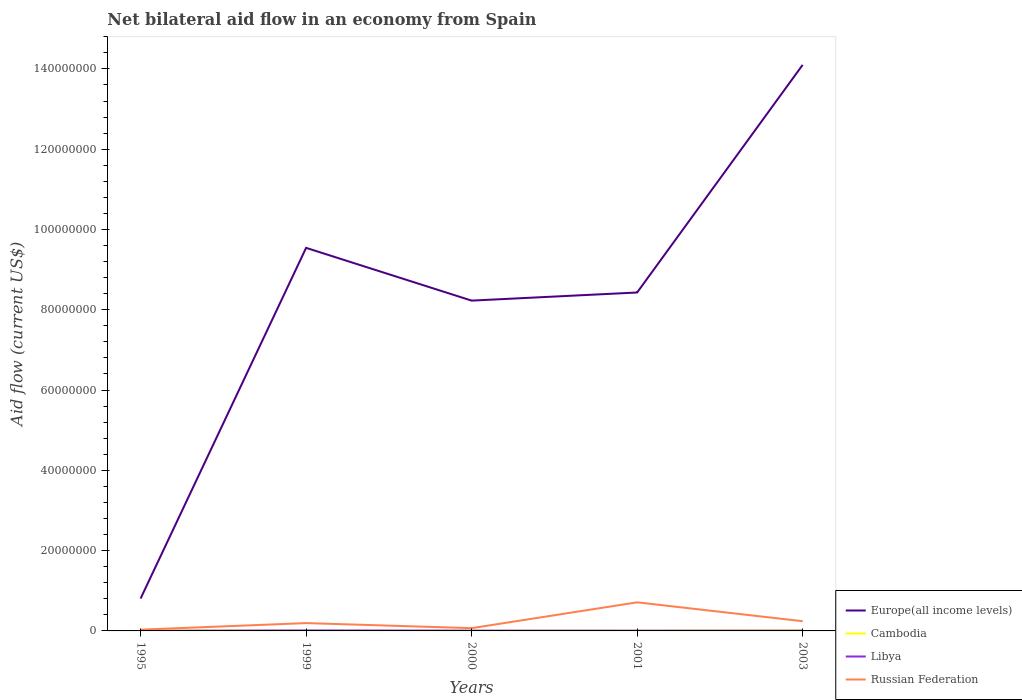How many different coloured lines are there?
Offer a terse response. 4. Is the number of lines equal to the number of legend labels?
Your answer should be very brief. Yes. Across all years, what is the maximum net bilateral aid flow in Europe(all income levels)?
Offer a very short reply. 8.07e+06. What is the total net bilateral aid flow in Europe(all income levels) in the graph?
Offer a very short reply. 1.31e+07. What is the difference between the highest and the second highest net bilateral aid flow in Russian Federation?
Keep it short and to the point. 6.81e+06. What is the difference between the highest and the lowest net bilateral aid flow in Libya?
Offer a terse response. 2. Is the net bilateral aid flow in Europe(all income levels) strictly greater than the net bilateral aid flow in Libya over the years?
Provide a short and direct response. No. How many years are there in the graph?
Your answer should be very brief. 5. What is the title of the graph?
Keep it short and to the point. Net bilateral aid flow in an economy from Spain. What is the Aid flow (current US$) of Europe(all income levels) in 1995?
Give a very brief answer. 8.07e+06. What is the Aid flow (current US$) in Cambodia in 1995?
Offer a terse response. 1.20e+05. What is the Aid flow (current US$) in Libya in 1995?
Provide a succinct answer. 2.00e+04. What is the Aid flow (current US$) in Europe(all income levels) in 1999?
Provide a succinct answer. 9.54e+07. What is the Aid flow (current US$) in Cambodia in 1999?
Ensure brevity in your answer.  2.00e+04. What is the Aid flow (current US$) in Libya in 1999?
Make the answer very short. 1.20e+05. What is the Aid flow (current US$) in Russian Federation in 1999?
Make the answer very short. 1.95e+06. What is the Aid flow (current US$) of Europe(all income levels) in 2000?
Make the answer very short. 8.23e+07. What is the Aid flow (current US$) of Libya in 2000?
Ensure brevity in your answer.  7.00e+04. What is the Aid flow (current US$) in Russian Federation in 2000?
Give a very brief answer. 6.90e+05. What is the Aid flow (current US$) of Europe(all income levels) in 2001?
Ensure brevity in your answer.  8.43e+07. What is the Aid flow (current US$) of Libya in 2001?
Your answer should be very brief. 6.00e+04. What is the Aid flow (current US$) of Russian Federation in 2001?
Your response must be concise. 7.12e+06. What is the Aid flow (current US$) in Europe(all income levels) in 2003?
Your response must be concise. 1.41e+08. What is the Aid flow (current US$) of Cambodia in 2003?
Your answer should be compact. 1.20e+05. What is the Aid flow (current US$) in Libya in 2003?
Offer a very short reply. 6.00e+04. What is the Aid flow (current US$) of Russian Federation in 2003?
Ensure brevity in your answer.  2.42e+06. Across all years, what is the maximum Aid flow (current US$) in Europe(all income levels)?
Provide a short and direct response. 1.41e+08. Across all years, what is the maximum Aid flow (current US$) in Cambodia?
Offer a terse response. 1.20e+05. Across all years, what is the maximum Aid flow (current US$) of Russian Federation?
Give a very brief answer. 7.12e+06. Across all years, what is the minimum Aid flow (current US$) of Europe(all income levels)?
Give a very brief answer. 8.07e+06. Across all years, what is the minimum Aid flow (current US$) of Cambodia?
Offer a very short reply. 2.00e+04. Across all years, what is the minimum Aid flow (current US$) of Libya?
Ensure brevity in your answer.  2.00e+04. What is the total Aid flow (current US$) in Europe(all income levels) in the graph?
Your answer should be very brief. 4.11e+08. What is the total Aid flow (current US$) of Cambodia in the graph?
Your response must be concise. 3.50e+05. What is the total Aid flow (current US$) of Russian Federation in the graph?
Ensure brevity in your answer.  1.25e+07. What is the difference between the Aid flow (current US$) of Europe(all income levels) in 1995 and that in 1999?
Give a very brief answer. -8.74e+07. What is the difference between the Aid flow (current US$) in Russian Federation in 1995 and that in 1999?
Give a very brief answer. -1.64e+06. What is the difference between the Aid flow (current US$) in Europe(all income levels) in 1995 and that in 2000?
Keep it short and to the point. -7.42e+07. What is the difference between the Aid flow (current US$) of Libya in 1995 and that in 2000?
Give a very brief answer. -5.00e+04. What is the difference between the Aid flow (current US$) in Russian Federation in 1995 and that in 2000?
Ensure brevity in your answer.  -3.80e+05. What is the difference between the Aid flow (current US$) in Europe(all income levels) in 1995 and that in 2001?
Keep it short and to the point. -7.62e+07. What is the difference between the Aid flow (current US$) in Cambodia in 1995 and that in 2001?
Give a very brief answer. 6.00e+04. What is the difference between the Aid flow (current US$) of Russian Federation in 1995 and that in 2001?
Provide a succinct answer. -6.81e+06. What is the difference between the Aid flow (current US$) of Europe(all income levels) in 1995 and that in 2003?
Your response must be concise. -1.33e+08. What is the difference between the Aid flow (current US$) of Cambodia in 1995 and that in 2003?
Ensure brevity in your answer.  0. What is the difference between the Aid flow (current US$) of Libya in 1995 and that in 2003?
Provide a short and direct response. -4.00e+04. What is the difference between the Aid flow (current US$) of Russian Federation in 1995 and that in 2003?
Your answer should be compact. -2.11e+06. What is the difference between the Aid flow (current US$) of Europe(all income levels) in 1999 and that in 2000?
Your answer should be very brief. 1.31e+07. What is the difference between the Aid flow (current US$) in Cambodia in 1999 and that in 2000?
Ensure brevity in your answer.  -10000. What is the difference between the Aid flow (current US$) in Libya in 1999 and that in 2000?
Your response must be concise. 5.00e+04. What is the difference between the Aid flow (current US$) in Russian Federation in 1999 and that in 2000?
Your response must be concise. 1.26e+06. What is the difference between the Aid flow (current US$) of Europe(all income levels) in 1999 and that in 2001?
Your response must be concise. 1.11e+07. What is the difference between the Aid flow (current US$) in Cambodia in 1999 and that in 2001?
Offer a very short reply. -4.00e+04. What is the difference between the Aid flow (current US$) of Russian Federation in 1999 and that in 2001?
Give a very brief answer. -5.17e+06. What is the difference between the Aid flow (current US$) of Europe(all income levels) in 1999 and that in 2003?
Offer a terse response. -4.56e+07. What is the difference between the Aid flow (current US$) in Russian Federation in 1999 and that in 2003?
Make the answer very short. -4.70e+05. What is the difference between the Aid flow (current US$) in Europe(all income levels) in 2000 and that in 2001?
Give a very brief answer. -2.02e+06. What is the difference between the Aid flow (current US$) of Cambodia in 2000 and that in 2001?
Your response must be concise. -3.00e+04. What is the difference between the Aid flow (current US$) of Libya in 2000 and that in 2001?
Make the answer very short. 10000. What is the difference between the Aid flow (current US$) of Russian Federation in 2000 and that in 2001?
Give a very brief answer. -6.43e+06. What is the difference between the Aid flow (current US$) of Europe(all income levels) in 2000 and that in 2003?
Provide a succinct answer. -5.87e+07. What is the difference between the Aid flow (current US$) of Russian Federation in 2000 and that in 2003?
Provide a succinct answer. -1.73e+06. What is the difference between the Aid flow (current US$) in Europe(all income levels) in 2001 and that in 2003?
Your response must be concise. -5.67e+07. What is the difference between the Aid flow (current US$) in Libya in 2001 and that in 2003?
Your response must be concise. 0. What is the difference between the Aid flow (current US$) in Russian Federation in 2001 and that in 2003?
Provide a succinct answer. 4.70e+06. What is the difference between the Aid flow (current US$) of Europe(all income levels) in 1995 and the Aid flow (current US$) of Cambodia in 1999?
Keep it short and to the point. 8.05e+06. What is the difference between the Aid flow (current US$) of Europe(all income levels) in 1995 and the Aid flow (current US$) of Libya in 1999?
Provide a short and direct response. 7.95e+06. What is the difference between the Aid flow (current US$) of Europe(all income levels) in 1995 and the Aid flow (current US$) of Russian Federation in 1999?
Provide a succinct answer. 6.12e+06. What is the difference between the Aid flow (current US$) in Cambodia in 1995 and the Aid flow (current US$) in Libya in 1999?
Your answer should be very brief. 0. What is the difference between the Aid flow (current US$) in Cambodia in 1995 and the Aid flow (current US$) in Russian Federation in 1999?
Provide a short and direct response. -1.83e+06. What is the difference between the Aid flow (current US$) in Libya in 1995 and the Aid flow (current US$) in Russian Federation in 1999?
Your answer should be compact. -1.93e+06. What is the difference between the Aid flow (current US$) of Europe(all income levels) in 1995 and the Aid flow (current US$) of Cambodia in 2000?
Provide a short and direct response. 8.04e+06. What is the difference between the Aid flow (current US$) of Europe(all income levels) in 1995 and the Aid flow (current US$) of Libya in 2000?
Your answer should be compact. 8.00e+06. What is the difference between the Aid flow (current US$) of Europe(all income levels) in 1995 and the Aid flow (current US$) of Russian Federation in 2000?
Make the answer very short. 7.38e+06. What is the difference between the Aid flow (current US$) of Cambodia in 1995 and the Aid flow (current US$) of Russian Federation in 2000?
Keep it short and to the point. -5.70e+05. What is the difference between the Aid flow (current US$) of Libya in 1995 and the Aid flow (current US$) of Russian Federation in 2000?
Your response must be concise. -6.70e+05. What is the difference between the Aid flow (current US$) of Europe(all income levels) in 1995 and the Aid flow (current US$) of Cambodia in 2001?
Provide a short and direct response. 8.01e+06. What is the difference between the Aid flow (current US$) of Europe(all income levels) in 1995 and the Aid flow (current US$) of Libya in 2001?
Provide a succinct answer. 8.01e+06. What is the difference between the Aid flow (current US$) of Europe(all income levels) in 1995 and the Aid flow (current US$) of Russian Federation in 2001?
Offer a very short reply. 9.50e+05. What is the difference between the Aid flow (current US$) of Cambodia in 1995 and the Aid flow (current US$) of Russian Federation in 2001?
Make the answer very short. -7.00e+06. What is the difference between the Aid flow (current US$) of Libya in 1995 and the Aid flow (current US$) of Russian Federation in 2001?
Offer a terse response. -7.10e+06. What is the difference between the Aid flow (current US$) in Europe(all income levels) in 1995 and the Aid flow (current US$) in Cambodia in 2003?
Offer a very short reply. 7.95e+06. What is the difference between the Aid flow (current US$) in Europe(all income levels) in 1995 and the Aid flow (current US$) in Libya in 2003?
Ensure brevity in your answer.  8.01e+06. What is the difference between the Aid flow (current US$) of Europe(all income levels) in 1995 and the Aid flow (current US$) of Russian Federation in 2003?
Provide a short and direct response. 5.65e+06. What is the difference between the Aid flow (current US$) in Cambodia in 1995 and the Aid flow (current US$) in Russian Federation in 2003?
Keep it short and to the point. -2.30e+06. What is the difference between the Aid flow (current US$) of Libya in 1995 and the Aid flow (current US$) of Russian Federation in 2003?
Provide a succinct answer. -2.40e+06. What is the difference between the Aid flow (current US$) in Europe(all income levels) in 1999 and the Aid flow (current US$) in Cambodia in 2000?
Provide a succinct answer. 9.54e+07. What is the difference between the Aid flow (current US$) of Europe(all income levels) in 1999 and the Aid flow (current US$) of Libya in 2000?
Ensure brevity in your answer.  9.54e+07. What is the difference between the Aid flow (current US$) in Europe(all income levels) in 1999 and the Aid flow (current US$) in Russian Federation in 2000?
Ensure brevity in your answer.  9.47e+07. What is the difference between the Aid flow (current US$) of Cambodia in 1999 and the Aid flow (current US$) of Libya in 2000?
Provide a short and direct response. -5.00e+04. What is the difference between the Aid flow (current US$) of Cambodia in 1999 and the Aid flow (current US$) of Russian Federation in 2000?
Your response must be concise. -6.70e+05. What is the difference between the Aid flow (current US$) in Libya in 1999 and the Aid flow (current US$) in Russian Federation in 2000?
Your answer should be very brief. -5.70e+05. What is the difference between the Aid flow (current US$) of Europe(all income levels) in 1999 and the Aid flow (current US$) of Cambodia in 2001?
Provide a short and direct response. 9.54e+07. What is the difference between the Aid flow (current US$) of Europe(all income levels) in 1999 and the Aid flow (current US$) of Libya in 2001?
Your answer should be compact. 9.54e+07. What is the difference between the Aid flow (current US$) in Europe(all income levels) in 1999 and the Aid flow (current US$) in Russian Federation in 2001?
Make the answer very short. 8.83e+07. What is the difference between the Aid flow (current US$) in Cambodia in 1999 and the Aid flow (current US$) in Libya in 2001?
Offer a terse response. -4.00e+04. What is the difference between the Aid flow (current US$) of Cambodia in 1999 and the Aid flow (current US$) of Russian Federation in 2001?
Give a very brief answer. -7.10e+06. What is the difference between the Aid flow (current US$) of Libya in 1999 and the Aid flow (current US$) of Russian Federation in 2001?
Make the answer very short. -7.00e+06. What is the difference between the Aid flow (current US$) in Europe(all income levels) in 1999 and the Aid flow (current US$) in Cambodia in 2003?
Your response must be concise. 9.53e+07. What is the difference between the Aid flow (current US$) in Europe(all income levels) in 1999 and the Aid flow (current US$) in Libya in 2003?
Ensure brevity in your answer.  9.54e+07. What is the difference between the Aid flow (current US$) of Europe(all income levels) in 1999 and the Aid flow (current US$) of Russian Federation in 2003?
Your answer should be compact. 9.30e+07. What is the difference between the Aid flow (current US$) in Cambodia in 1999 and the Aid flow (current US$) in Libya in 2003?
Offer a very short reply. -4.00e+04. What is the difference between the Aid flow (current US$) in Cambodia in 1999 and the Aid flow (current US$) in Russian Federation in 2003?
Your answer should be very brief. -2.40e+06. What is the difference between the Aid flow (current US$) in Libya in 1999 and the Aid flow (current US$) in Russian Federation in 2003?
Offer a very short reply. -2.30e+06. What is the difference between the Aid flow (current US$) in Europe(all income levels) in 2000 and the Aid flow (current US$) in Cambodia in 2001?
Offer a very short reply. 8.22e+07. What is the difference between the Aid flow (current US$) in Europe(all income levels) in 2000 and the Aid flow (current US$) in Libya in 2001?
Your response must be concise. 8.22e+07. What is the difference between the Aid flow (current US$) in Europe(all income levels) in 2000 and the Aid flow (current US$) in Russian Federation in 2001?
Ensure brevity in your answer.  7.52e+07. What is the difference between the Aid flow (current US$) in Cambodia in 2000 and the Aid flow (current US$) in Libya in 2001?
Ensure brevity in your answer.  -3.00e+04. What is the difference between the Aid flow (current US$) in Cambodia in 2000 and the Aid flow (current US$) in Russian Federation in 2001?
Your answer should be very brief. -7.09e+06. What is the difference between the Aid flow (current US$) of Libya in 2000 and the Aid flow (current US$) of Russian Federation in 2001?
Your answer should be very brief. -7.05e+06. What is the difference between the Aid flow (current US$) of Europe(all income levels) in 2000 and the Aid flow (current US$) of Cambodia in 2003?
Provide a short and direct response. 8.22e+07. What is the difference between the Aid flow (current US$) of Europe(all income levels) in 2000 and the Aid flow (current US$) of Libya in 2003?
Your answer should be very brief. 8.22e+07. What is the difference between the Aid flow (current US$) of Europe(all income levels) in 2000 and the Aid flow (current US$) of Russian Federation in 2003?
Your response must be concise. 7.99e+07. What is the difference between the Aid flow (current US$) in Cambodia in 2000 and the Aid flow (current US$) in Russian Federation in 2003?
Ensure brevity in your answer.  -2.39e+06. What is the difference between the Aid flow (current US$) in Libya in 2000 and the Aid flow (current US$) in Russian Federation in 2003?
Offer a very short reply. -2.35e+06. What is the difference between the Aid flow (current US$) in Europe(all income levels) in 2001 and the Aid flow (current US$) in Cambodia in 2003?
Keep it short and to the point. 8.42e+07. What is the difference between the Aid flow (current US$) of Europe(all income levels) in 2001 and the Aid flow (current US$) of Libya in 2003?
Ensure brevity in your answer.  8.42e+07. What is the difference between the Aid flow (current US$) of Europe(all income levels) in 2001 and the Aid flow (current US$) of Russian Federation in 2003?
Provide a succinct answer. 8.19e+07. What is the difference between the Aid flow (current US$) of Cambodia in 2001 and the Aid flow (current US$) of Libya in 2003?
Give a very brief answer. 0. What is the difference between the Aid flow (current US$) of Cambodia in 2001 and the Aid flow (current US$) of Russian Federation in 2003?
Give a very brief answer. -2.36e+06. What is the difference between the Aid flow (current US$) in Libya in 2001 and the Aid flow (current US$) in Russian Federation in 2003?
Give a very brief answer. -2.36e+06. What is the average Aid flow (current US$) in Europe(all income levels) per year?
Keep it short and to the point. 8.22e+07. What is the average Aid flow (current US$) in Libya per year?
Your answer should be compact. 6.60e+04. What is the average Aid flow (current US$) of Russian Federation per year?
Ensure brevity in your answer.  2.50e+06. In the year 1995, what is the difference between the Aid flow (current US$) of Europe(all income levels) and Aid flow (current US$) of Cambodia?
Give a very brief answer. 7.95e+06. In the year 1995, what is the difference between the Aid flow (current US$) in Europe(all income levels) and Aid flow (current US$) in Libya?
Provide a succinct answer. 8.05e+06. In the year 1995, what is the difference between the Aid flow (current US$) of Europe(all income levels) and Aid flow (current US$) of Russian Federation?
Offer a very short reply. 7.76e+06. In the year 1995, what is the difference between the Aid flow (current US$) in Cambodia and Aid flow (current US$) in Russian Federation?
Offer a very short reply. -1.90e+05. In the year 1995, what is the difference between the Aid flow (current US$) of Libya and Aid flow (current US$) of Russian Federation?
Provide a short and direct response. -2.90e+05. In the year 1999, what is the difference between the Aid flow (current US$) in Europe(all income levels) and Aid flow (current US$) in Cambodia?
Provide a succinct answer. 9.54e+07. In the year 1999, what is the difference between the Aid flow (current US$) in Europe(all income levels) and Aid flow (current US$) in Libya?
Your answer should be very brief. 9.53e+07. In the year 1999, what is the difference between the Aid flow (current US$) of Europe(all income levels) and Aid flow (current US$) of Russian Federation?
Ensure brevity in your answer.  9.35e+07. In the year 1999, what is the difference between the Aid flow (current US$) of Cambodia and Aid flow (current US$) of Libya?
Ensure brevity in your answer.  -1.00e+05. In the year 1999, what is the difference between the Aid flow (current US$) of Cambodia and Aid flow (current US$) of Russian Federation?
Keep it short and to the point. -1.93e+06. In the year 1999, what is the difference between the Aid flow (current US$) in Libya and Aid flow (current US$) in Russian Federation?
Provide a short and direct response. -1.83e+06. In the year 2000, what is the difference between the Aid flow (current US$) in Europe(all income levels) and Aid flow (current US$) in Cambodia?
Make the answer very short. 8.22e+07. In the year 2000, what is the difference between the Aid flow (current US$) in Europe(all income levels) and Aid flow (current US$) in Libya?
Your response must be concise. 8.22e+07. In the year 2000, what is the difference between the Aid flow (current US$) in Europe(all income levels) and Aid flow (current US$) in Russian Federation?
Provide a succinct answer. 8.16e+07. In the year 2000, what is the difference between the Aid flow (current US$) of Cambodia and Aid flow (current US$) of Russian Federation?
Give a very brief answer. -6.60e+05. In the year 2000, what is the difference between the Aid flow (current US$) of Libya and Aid flow (current US$) of Russian Federation?
Make the answer very short. -6.20e+05. In the year 2001, what is the difference between the Aid flow (current US$) of Europe(all income levels) and Aid flow (current US$) of Cambodia?
Keep it short and to the point. 8.42e+07. In the year 2001, what is the difference between the Aid flow (current US$) in Europe(all income levels) and Aid flow (current US$) in Libya?
Provide a succinct answer. 8.42e+07. In the year 2001, what is the difference between the Aid flow (current US$) of Europe(all income levels) and Aid flow (current US$) of Russian Federation?
Offer a very short reply. 7.72e+07. In the year 2001, what is the difference between the Aid flow (current US$) in Cambodia and Aid flow (current US$) in Libya?
Keep it short and to the point. 0. In the year 2001, what is the difference between the Aid flow (current US$) of Cambodia and Aid flow (current US$) of Russian Federation?
Offer a very short reply. -7.06e+06. In the year 2001, what is the difference between the Aid flow (current US$) of Libya and Aid flow (current US$) of Russian Federation?
Ensure brevity in your answer.  -7.06e+06. In the year 2003, what is the difference between the Aid flow (current US$) in Europe(all income levels) and Aid flow (current US$) in Cambodia?
Your response must be concise. 1.41e+08. In the year 2003, what is the difference between the Aid flow (current US$) in Europe(all income levels) and Aid flow (current US$) in Libya?
Your answer should be very brief. 1.41e+08. In the year 2003, what is the difference between the Aid flow (current US$) in Europe(all income levels) and Aid flow (current US$) in Russian Federation?
Offer a very short reply. 1.39e+08. In the year 2003, what is the difference between the Aid flow (current US$) in Cambodia and Aid flow (current US$) in Russian Federation?
Ensure brevity in your answer.  -2.30e+06. In the year 2003, what is the difference between the Aid flow (current US$) of Libya and Aid flow (current US$) of Russian Federation?
Provide a short and direct response. -2.36e+06. What is the ratio of the Aid flow (current US$) of Europe(all income levels) in 1995 to that in 1999?
Your response must be concise. 0.08. What is the ratio of the Aid flow (current US$) in Cambodia in 1995 to that in 1999?
Your answer should be compact. 6. What is the ratio of the Aid flow (current US$) of Russian Federation in 1995 to that in 1999?
Ensure brevity in your answer.  0.16. What is the ratio of the Aid flow (current US$) of Europe(all income levels) in 1995 to that in 2000?
Provide a short and direct response. 0.1. What is the ratio of the Aid flow (current US$) in Libya in 1995 to that in 2000?
Offer a very short reply. 0.29. What is the ratio of the Aid flow (current US$) in Russian Federation in 1995 to that in 2000?
Offer a very short reply. 0.45. What is the ratio of the Aid flow (current US$) of Europe(all income levels) in 1995 to that in 2001?
Your response must be concise. 0.1. What is the ratio of the Aid flow (current US$) of Libya in 1995 to that in 2001?
Ensure brevity in your answer.  0.33. What is the ratio of the Aid flow (current US$) of Russian Federation in 1995 to that in 2001?
Keep it short and to the point. 0.04. What is the ratio of the Aid flow (current US$) in Europe(all income levels) in 1995 to that in 2003?
Provide a short and direct response. 0.06. What is the ratio of the Aid flow (current US$) in Cambodia in 1995 to that in 2003?
Your response must be concise. 1. What is the ratio of the Aid flow (current US$) of Libya in 1995 to that in 2003?
Your answer should be very brief. 0.33. What is the ratio of the Aid flow (current US$) in Russian Federation in 1995 to that in 2003?
Provide a short and direct response. 0.13. What is the ratio of the Aid flow (current US$) of Europe(all income levels) in 1999 to that in 2000?
Give a very brief answer. 1.16. What is the ratio of the Aid flow (current US$) in Libya in 1999 to that in 2000?
Provide a succinct answer. 1.71. What is the ratio of the Aid flow (current US$) of Russian Federation in 1999 to that in 2000?
Offer a terse response. 2.83. What is the ratio of the Aid flow (current US$) of Europe(all income levels) in 1999 to that in 2001?
Provide a succinct answer. 1.13. What is the ratio of the Aid flow (current US$) of Russian Federation in 1999 to that in 2001?
Provide a short and direct response. 0.27. What is the ratio of the Aid flow (current US$) of Europe(all income levels) in 1999 to that in 2003?
Ensure brevity in your answer.  0.68. What is the ratio of the Aid flow (current US$) of Cambodia in 1999 to that in 2003?
Offer a terse response. 0.17. What is the ratio of the Aid flow (current US$) of Russian Federation in 1999 to that in 2003?
Provide a succinct answer. 0.81. What is the ratio of the Aid flow (current US$) of Cambodia in 2000 to that in 2001?
Keep it short and to the point. 0.5. What is the ratio of the Aid flow (current US$) in Libya in 2000 to that in 2001?
Ensure brevity in your answer.  1.17. What is the ratio of the Aid flow (current US$) in Russian Federation in 2000 to that in 2001?
Your answer should be very brief. 0.1. What is the ratio of the Aid flow (current US$) of Europe(all income levels) in 2000 to that in 2003?
Offer a terse response. 0.58. What is the ratio of the Aid flow (current US$) of Russian Federation in 2000 to that in 2003?
Offer a terse response. 0.29. What is the ratio of the Aid flow (current US$) in Europe(all income levels) in 2001 to that in 2003?
Your response must be concise. 0.6. What is the ratio of the Aid flow (current US$) in Russian Federation in 2001 to that in 2003?
Keep it short and to the point. 2.94. What is the difference between the highest and the second highest Aid flow (current US$) in Europe(all income levels)?
Provide a short and direct response. 4.56e+07. What is the difference between the highest and the second highest Aid flow (current US$) in Cambodia?
Provide a succinct answer. 0. What is the difference between the highest and the second highest Aid flow (current US$) in Russian Federation?
Ensure brevity in your answer.  4.70e+06. What is the difference between the highest and the lowest Aid flow (current US$) of Europe(all income levels)?
Provide a succinct answer. 1.33e+08. What is the difference between the highest and the lowest Aid flow (current US$) of Libya?
Make the answer very short. 1.00e+05. What is the difference between the highest and the lowest Aid flow (current US$) of Russian Federation?
Offer a terse response. 6.81e+06. 